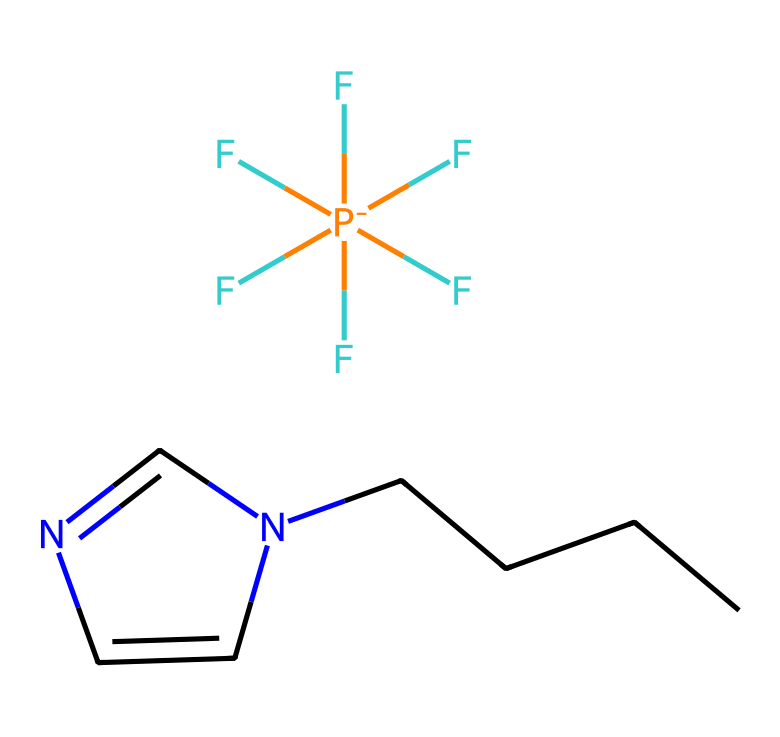What is the molecular formula of the ionic liquid? To derive the molecular formula, count the various atoms represented in the structure: Carbon (C), Nitrogen (N), Fluorine (F), and Phosphorus (P). The total counts yield C7H12F6N2P.
Answer: C7H12F6N2P How many carbon atoms are present in this ionic liquid? By examining the structure, we can see there are 7 carbon atoms in total, as indicated by the number of 'C' symbols in the SMILES representation.
Answer: 7 What type of ionic liquid structure does this represent? This is a 1-alkyl-3-methylimidazolium ionic liquid, as inferred from the presence of the imidazolium ring structure component in the molecule.
Answer: 1-alkyl-3-methylimidazolium What property of ionic liquids is indicated by the presence of fluorinated groups? The presence of multiple fluorine atoms generally indicates higher thermal stability and lower vapor pressure, characteristics important for high-performance adhesives in manufacturing.
Answer: increased stability How many nitrogen atoms are present in this ionic liquid? The SMILES representation shows that there are 2 nitrogen atoms, as indicated by the 'N' symbols appearing in the structure.
Answer: 2 What effect does the ionic liquid's structure have on adhesion properties? The unique combination of polar and non-polar regions in its structure enhances adhesion properties to substrates, making it effective in board game manufacturing.
Answer: improved adhesion What common application might utilize this ionic liquid in board game manufacturing? This ionic liquid could be used as a component in advanced adhesives, enhancing bonding in materials such as cardstock or plastic used in board games.
Answer: advanced adhesives 